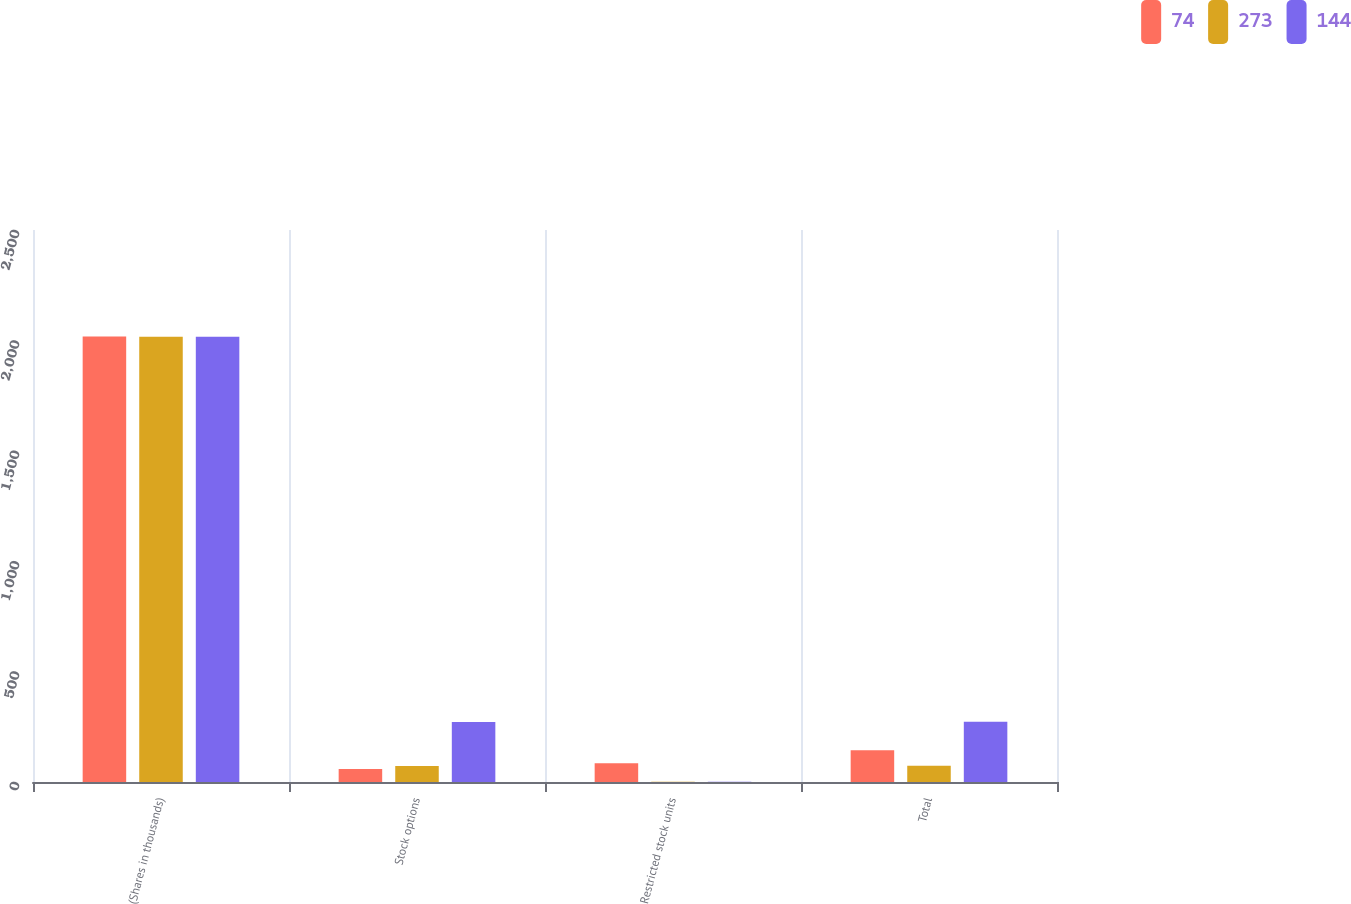Convert chart to OTSL. <chart><loc_0><loc_0><loc_500><loc_500><stacked_bar_chart><ecel><fcel>(Shares in thousands)<fcel>Stock options<fcel>Restricted stock units<fcel>Total<nl><fcel>74<fcel>2018<fcel>59<fcel>85<fcel>144<nl><fcel>273<fcel>2017<fcel>73<fcel>1<fcel>74<nl><fcel>144<fcel>2016<fcel>272<fcel>1<fcel>273<nl></chart> 